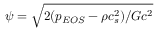<formula> <loc_0><loc_0><loc_500><loc_500>\psi = \sqrt { 2 ( { p _ { E O S } } - \rho c _ { s } ^ { 2 } ) / G { c ^ { 2 } } }</formula> 